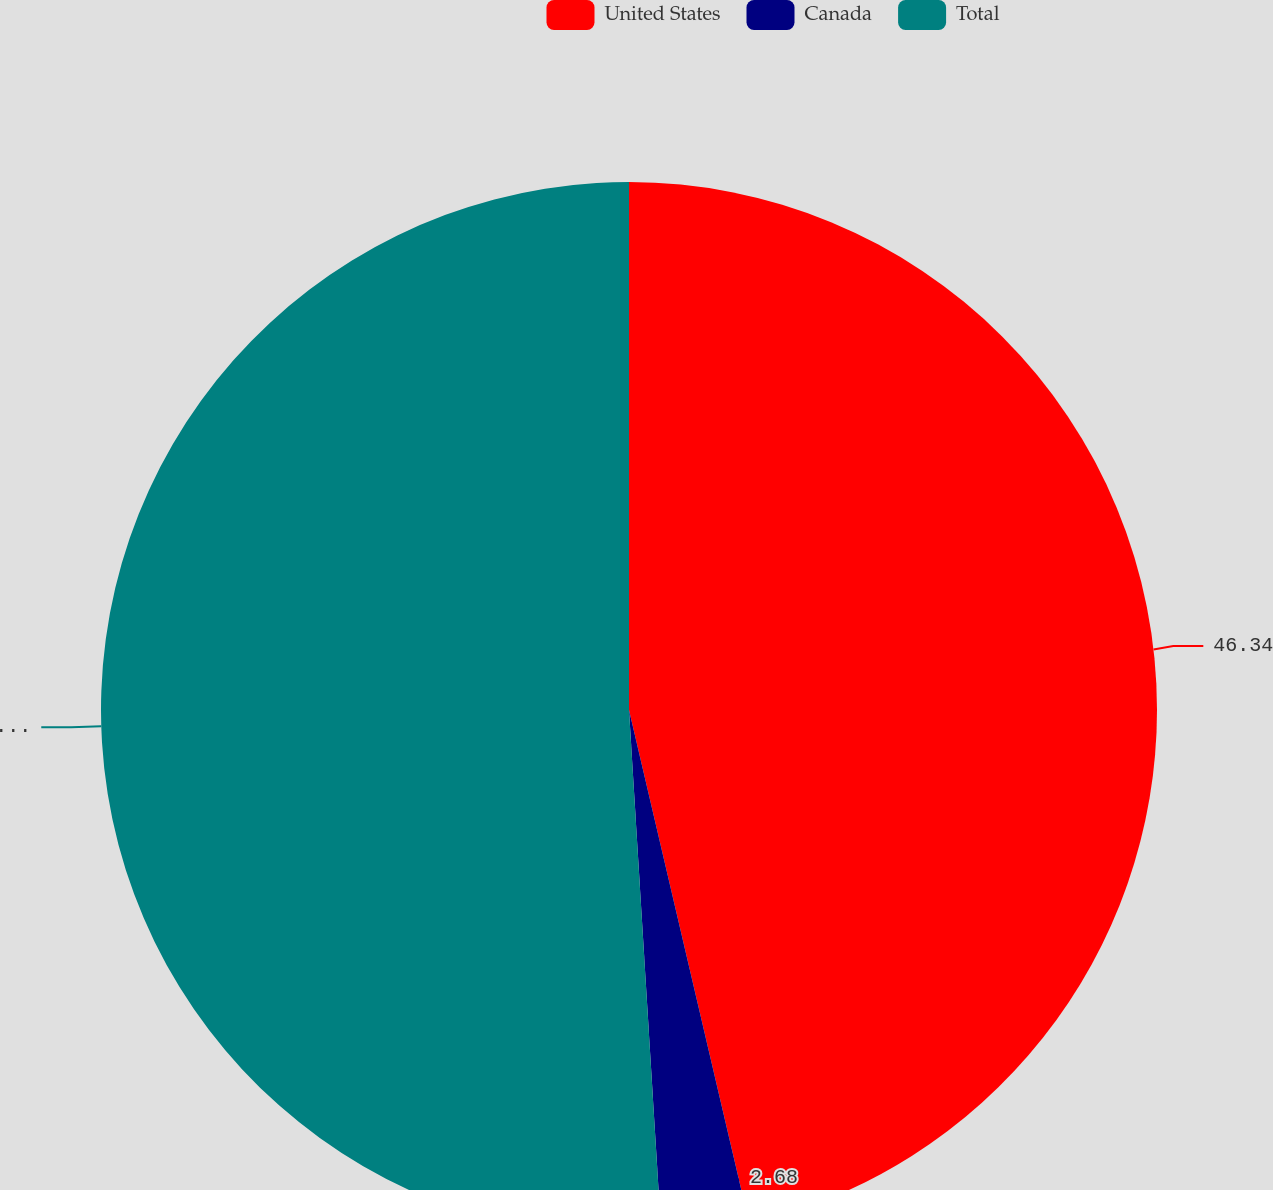Convert chart. <chart><loc_0><loc_0><loc_500><loc_500><pie_chart><fcel>United States<fcel>Canada<fcel>Total<nl><fcel>46.34%<fcel>2.68%<fcel>50.98%<nl></chart> 